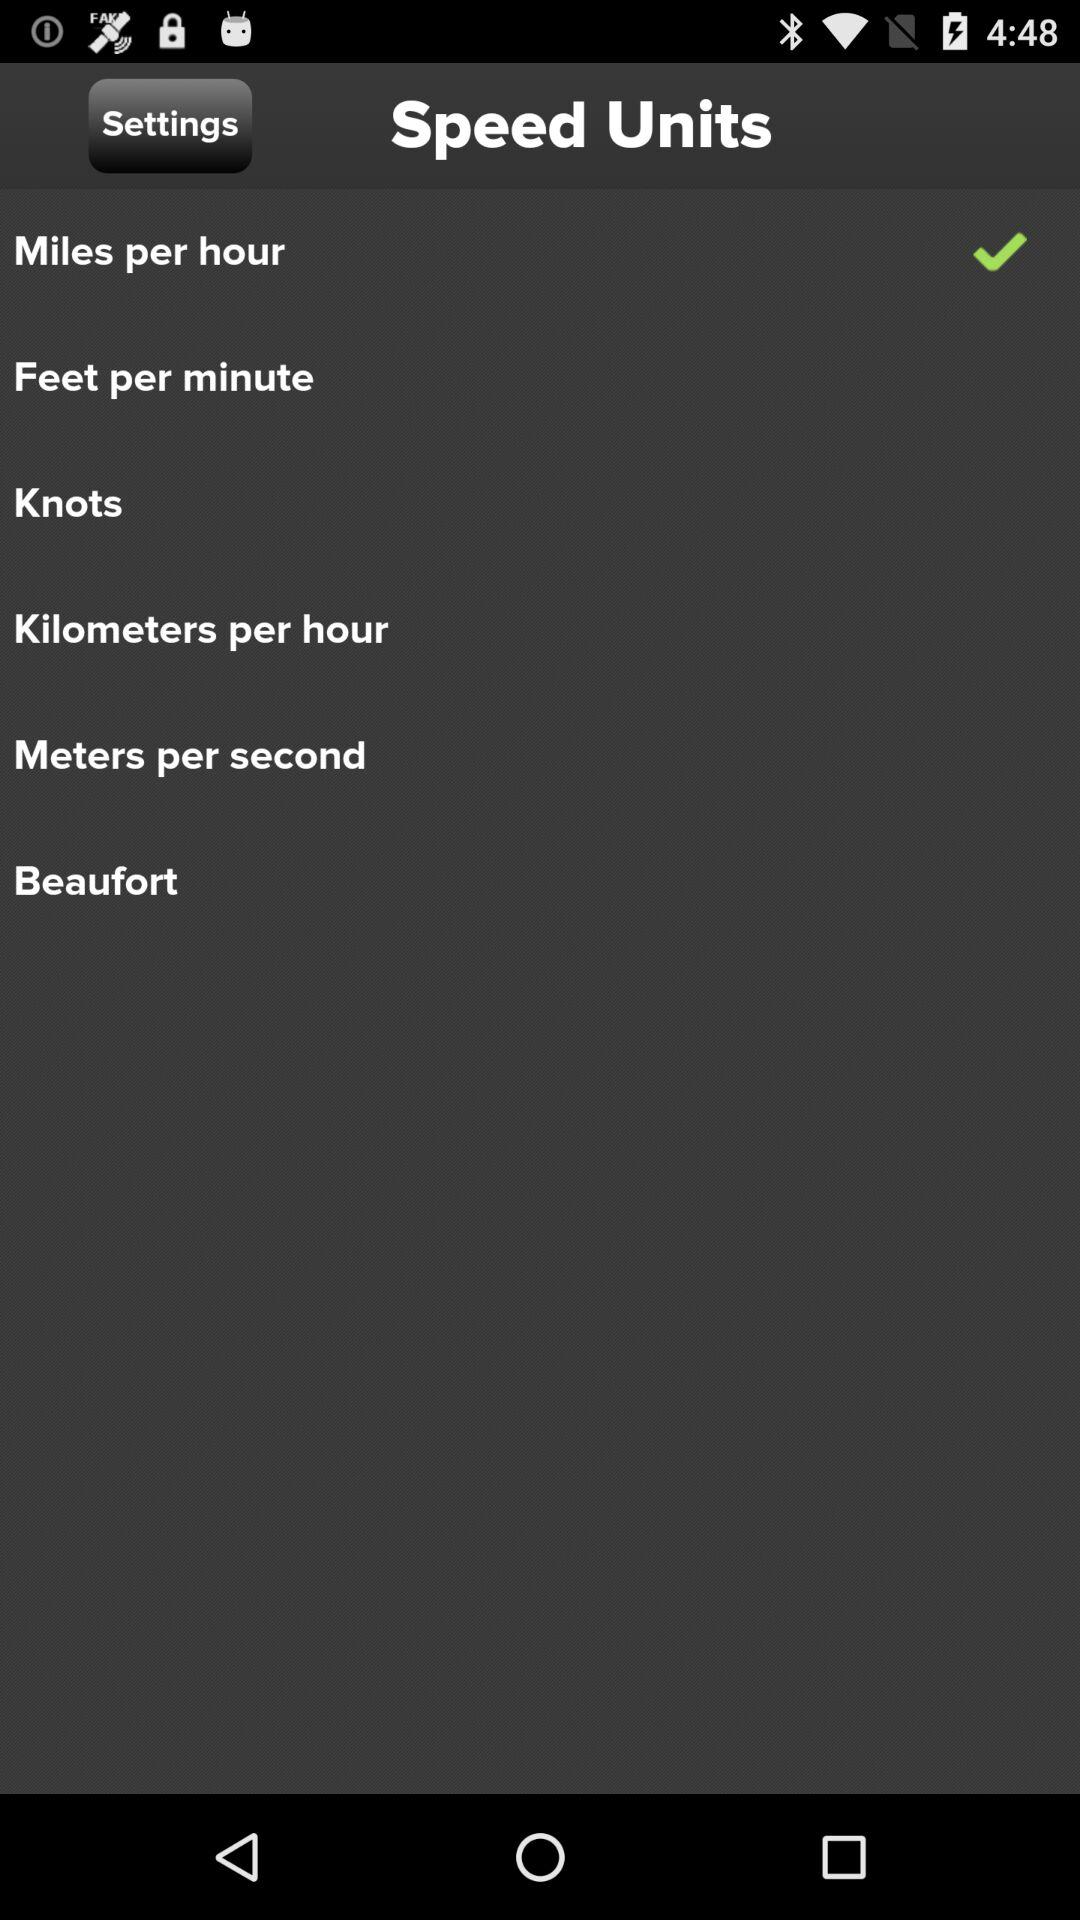Which option is selected? The selected option is "Miles per hour". 